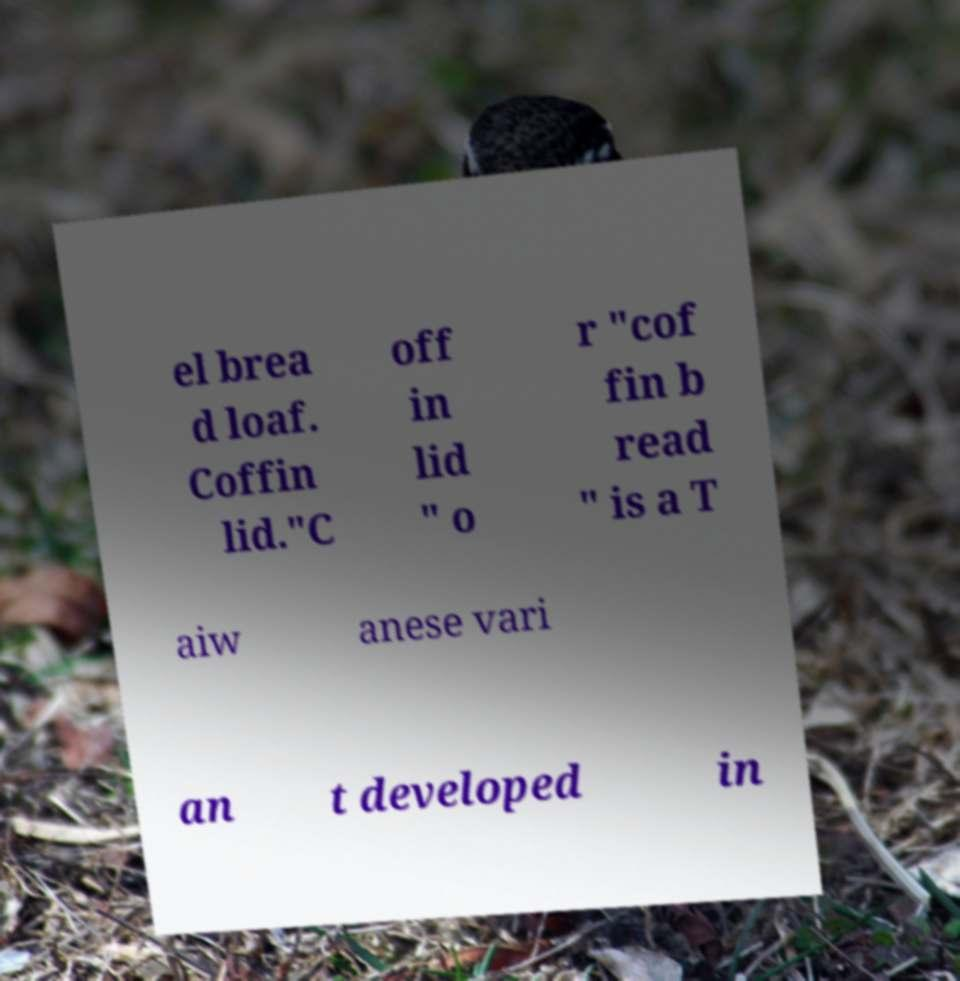For documentation purposes, I need the text within this image transcribed. Could you provide that? el brea d loaf. Coffin lid."C off in lid " o r "cof fin b read " is a T aiw anese vari an t developed in 